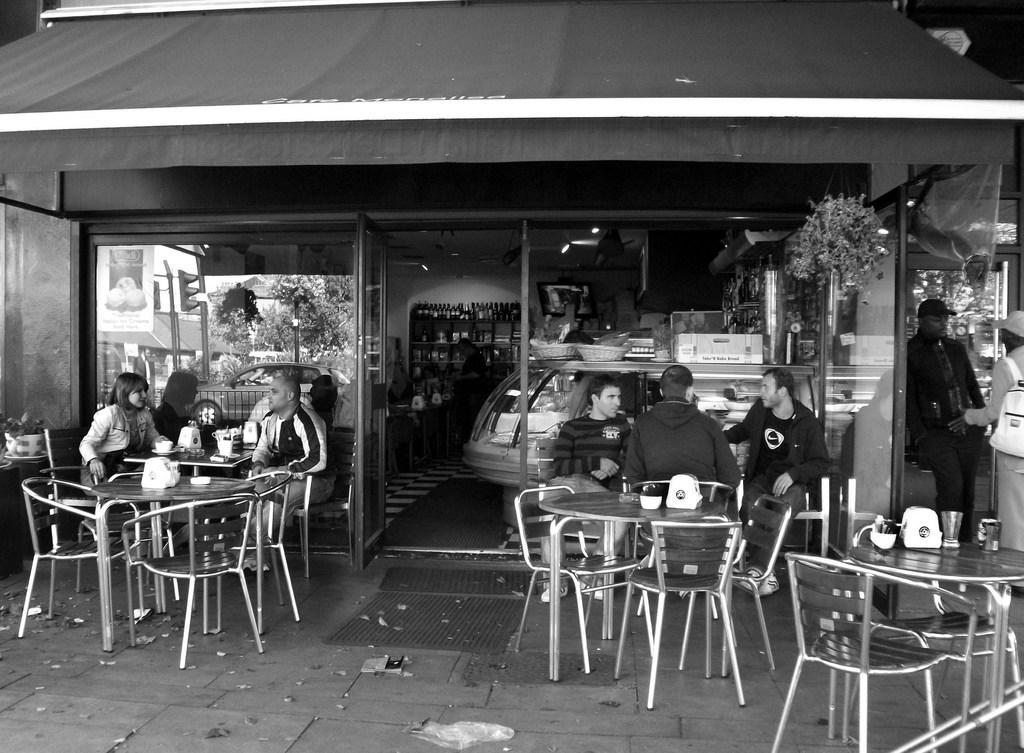How would you summarize this image in a sentence or two? Here we can see a group of people are sitting on the chair, and in front there is the table and some objects on it, and here is the door, and here are the bottles. 